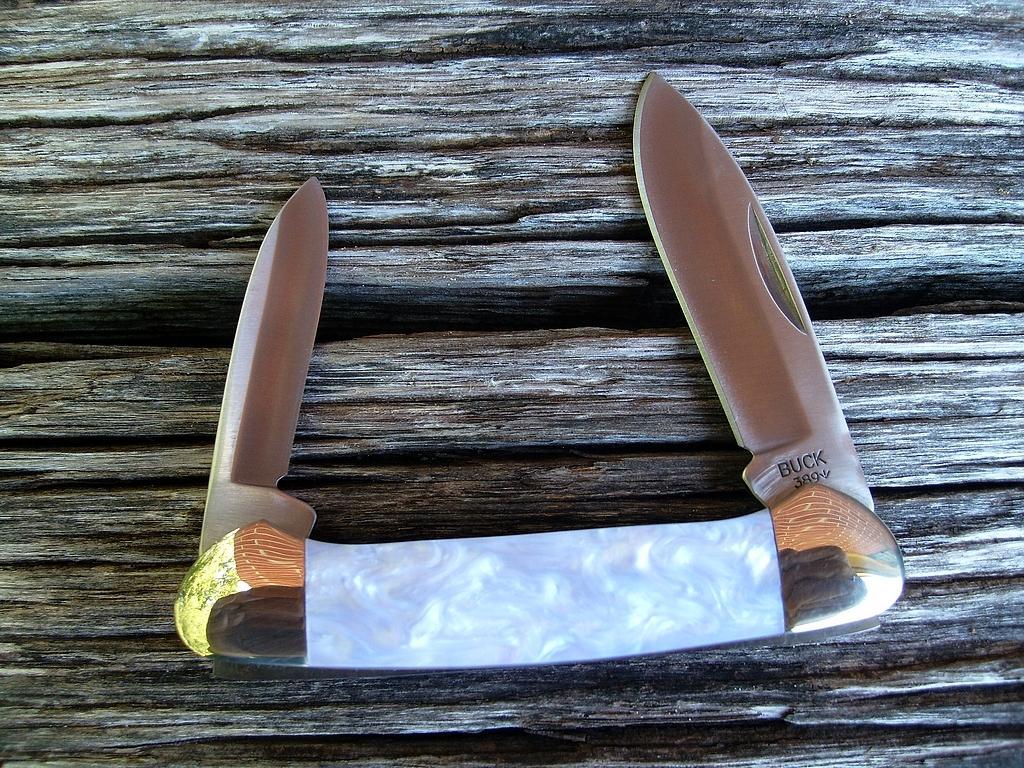Describe this image in one or two sentences. In this picture we can see knives on a wooden surface. 